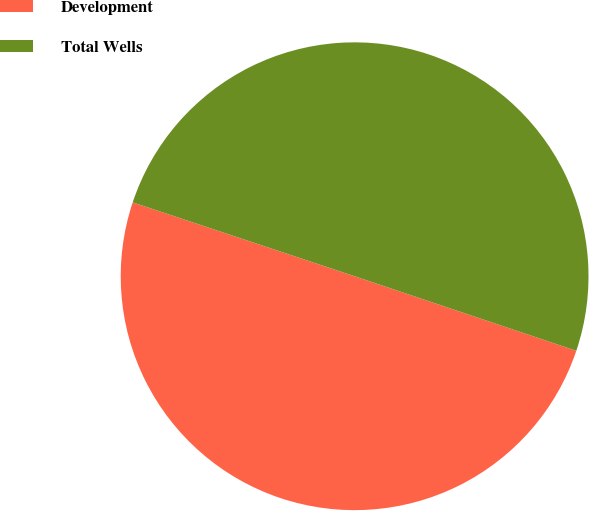<chart> <loc_0><loc_0><loc_500><loc_500><pie_chart><fcel>Development<fcel>Total Wells<nl><fcel>49.95%<fcel>50.05%<nl></chart> 